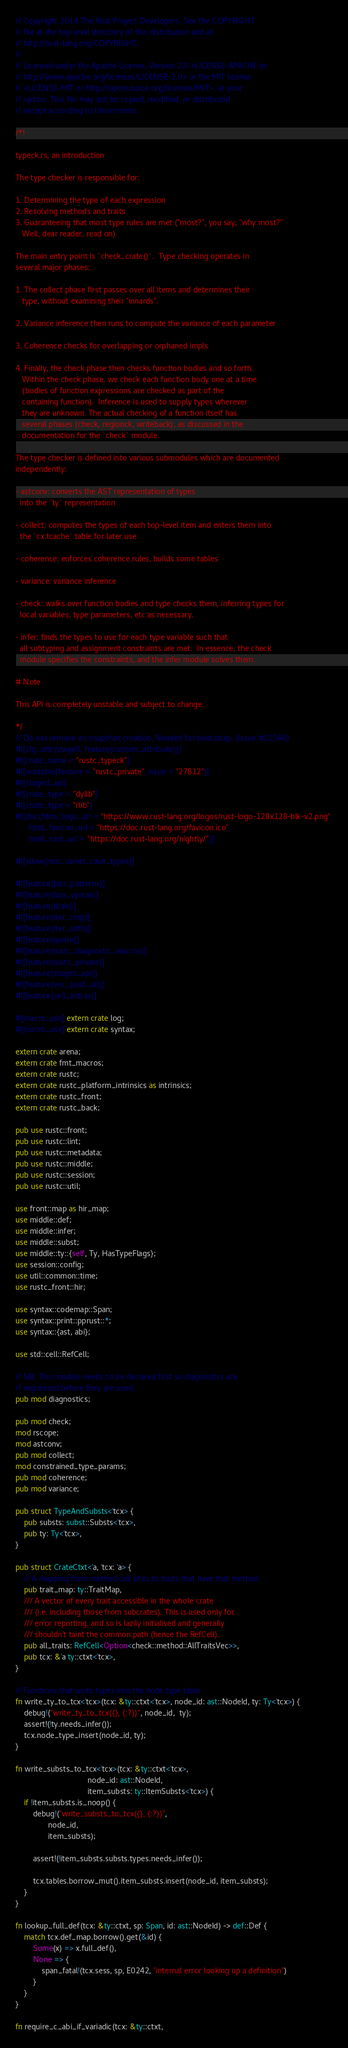Convert code to text. <code><loc_0><loc_0><loc_500><loc_500><_Rust_>// Copyright 2014 The Rust Project Developers. See the COPYRIGHT
// file at the top-level directory of this distribution and at
// http://rust-lang.org/COPYRIGHT.
//
// Licensed under the Apache License, Version 2.0 <LICENSE-APACHE or
// http://www.apache.org/licenses/LICENSE-2.0> or the MIT license
// <LICENSE-MIT or http://opensource.org/licenses/MIT>, at your
// option. This file may not be copied, modified, or distributed
// except according to those terms.

/*!

typeck.rs, an introduction

The type checker is responsible for:

1. Determining the type of each expression
2. Resolving methods and traits
3. Guaranteeing that most type rules are met ("most?", you say, "why most?"
   Well, dear reader, read on)

The main entry point is `check_crate()`.  Type checking operates in
several major phases:

1. The collect phase first passes over all items and determines their
   type, without examining their "innards".

2. Variance inference then runs to compute the variance of each parameter

3. Coherence checks for overlapping or orphaned impls

4. Finally, the check phase then checks function bodies and so forth.
   Within the check phase, we check each function body one at a time
   (bodies of function expressions are checked as part of the
   containing function).  Inference is used to supply types wherever
   they are unknown. The actual checking of a function itself has
   several phases (check, regionck, writeback), as discussed in the
   documentation for the `check` module.

The type checker is defined into various submodules which are documented
independently:

- astconv: converts the AST representation of types
  into the `ty` representation

- collect: computes the types of each top-level item and enters them into
  the `cx.tcache` table for later use

- coherence: enforces coherence rules, builds some tables

- variance: variance inference

- check: walks over function bodies and type checks them, inferring types for
  local variables, type parameters, etc as necessary.

- infer: finds the types to use for each type variable such that
  all subtyping and assignment constraints are met.  In essence, the check
  module specifies the constraints, and the infer module solves them.

# Note

This API is completely unstable and subject to change.

*/
// Do not remove on snapshot creation. Needed for bootstrap. (Issue #22364)
#![cfg_attr(stage0, feature(custom_attribute))]
#![crate_name = "rustc_typeck"]
#![unstable(feature = "rustc_private", issue = "27812")]
#![staged_api]
#![crate_type = "dylib"]
#![crate_type = "rlib"]
#![doc(html_logo_url = "https://www.rust-lang.org/logos/rust-logo-128x128-blk-v2.png",
      html_favicon_url = "https://doc.rust-lang.org/favicon.ico",
      html_root_url = "https://doc.rust-lang.org/nightly/")]

#![allow(non_camel_case_types)]

#![feature(box_patterns)]
#![feature(box_syntax)]
#![feature(drain)]
#![feature(iter_cmp)]
#![feature(iter_arith)]
#![feature(quote)]
#![feature(rustc_diagnostic_macros)]
#![feature(rustc_private)]
#![feature(staged_api)]
#![feature(vec_push_all)]
#![feature(cell_extras)]

#[macro_use] extern crate log;
#[macro_use] extern crate syntax;

extern crate arena;
extern crate fmt_macros;
extern crate rustc;
extern crate rustc_platform_intrinsics as intrinsics;
extern crate rustc_front;
extern crate rustc_back;

pub use rustc::front;
pub use rustc::lint;
pub use rustc::metadata;
pub use rustc::middle;
pub use rustc::session;
pub use rustc::util;

use front::map as hir_map;
use middle::def;
use middle::infer;
use middle::subst;
use middle::ty::{self, Ty, HasTypeFlags};
use session::config;
use util::common::time;
use rustc_front::hir;

use syntax::codemap::Span;
use syntax::print::pprust::*;
use syntax::{ast, abi};

use std::cell::RefCell;

// NB: This module needs to be declared first so diagnostics are
// registered before they are used.
pub mod diagnostics;

pub mod check;
mod rscope;
mod astconv;
pub mod collect;
mod constrained_type_params;
pub mod coherence;
pub mod variance;

pub struct TypeAndSubsts<'tcx> {
    pub substs: subst::Substs<'tcx>,
    pub ty: Ty<'tcx>,
}

pub struct CrateCtxt<'a, 'tcx: 'a> {
    // A mapping from method call sites to traits that have that method.
    pub trait_map: ty::TraitMap,
    /// A vector of every trait accessible in the whole crate
    /// (i.e. including those from subcrates). This is used only for
    /// error reporting, and so is lazily initialised and generally
    /// shouldn't taint the common path (hence the RefCell).
    pub all_traits: RefCell<Option<check::method::AllTraitsVec>>,
    pub tcx: &'a ty::ctxt<'tcx>,
}

// Functions that write types into the node type table
fn write_ty_to_tcx<'tcx>(tcx: &ty::ctxt<'tcx>, node_id: ast::NodeId, ty: Ty<'tcx>) {
    debug!("write_ty_to_tcx({}, {:?})", node_id,  ty);
    assert!(!ty.needs_infer());
    tcx.node_type_insert(node_id, ty);
}

fn write_substs_to_tcx<'tcx>(tcx: &ty::ctxt<'tcx>,
                                 node_id: ast::NodeId,
                                 item_substs: ty::ItemSubsts<'tcx>) {
    if !item_substs.is_noop() {
        debug!("write_substs_to_tcx({}, {:?})",
               node_id,
               item_substs);

        assert!(!item_substs.substs.types.needs_infer());

        tcx.tables.borrow_mut().item_substs.insert(node_id, item_substs);
    }
}

fn lookup_full_def(tcx: &ty::ctxt, sp: Span, id: ast::NodeId) -> def::Def {
    match tcx.def_map.borrow().get(&id) {
        Some(x) => x.full_def(),
        None => {
            span_fatal!(tcx.sess, sp, E0242, "internal error looking up a definition")
        }
    }
}

fn require_c_abi_if_variadic(tcx: &ty::ctxt,</code> 